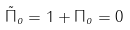Convert formula to latex. <formula><loc_0><loc_0><loc_500><loc_500>\tilde { \Pi } _ { o } = 1 + \Pi _ { o } = 0</formula> 